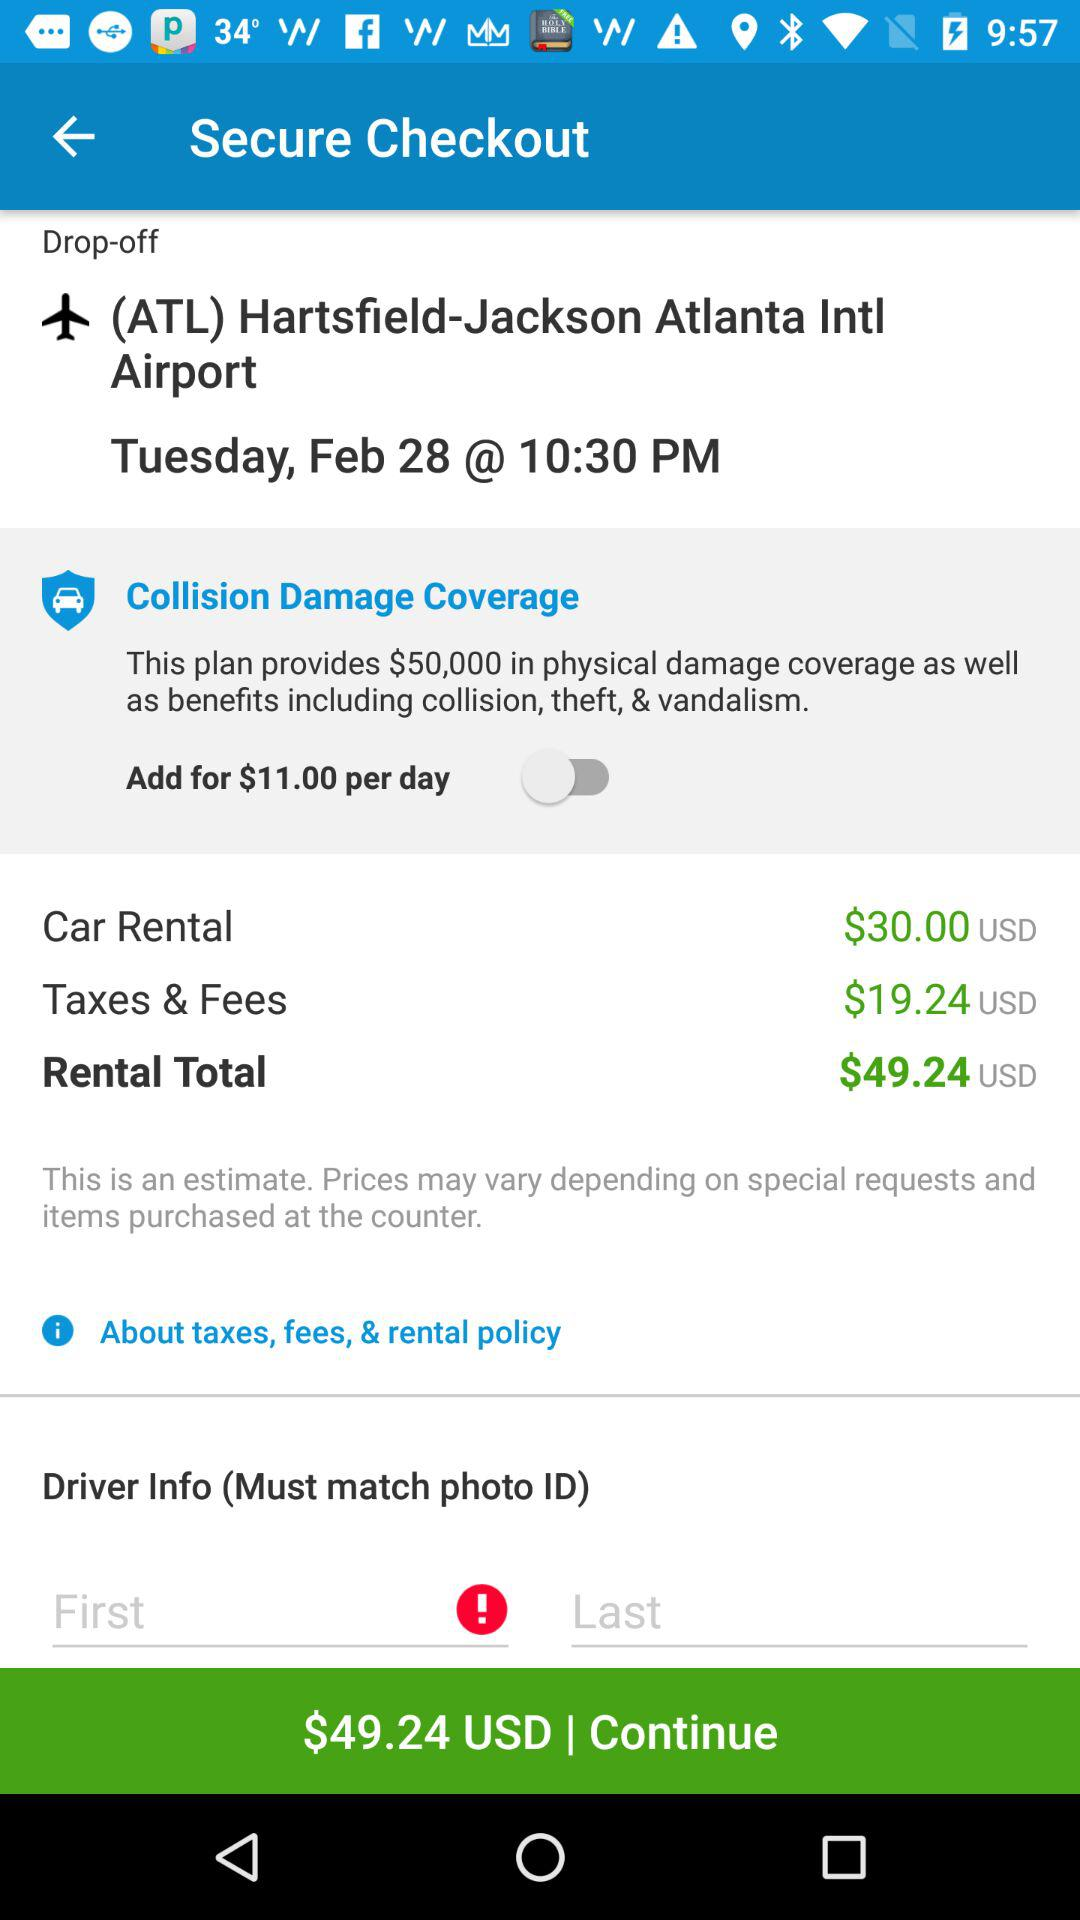What is the total amount of taxes and fees? The total amount of taxes and fees is $19.24 USD. 